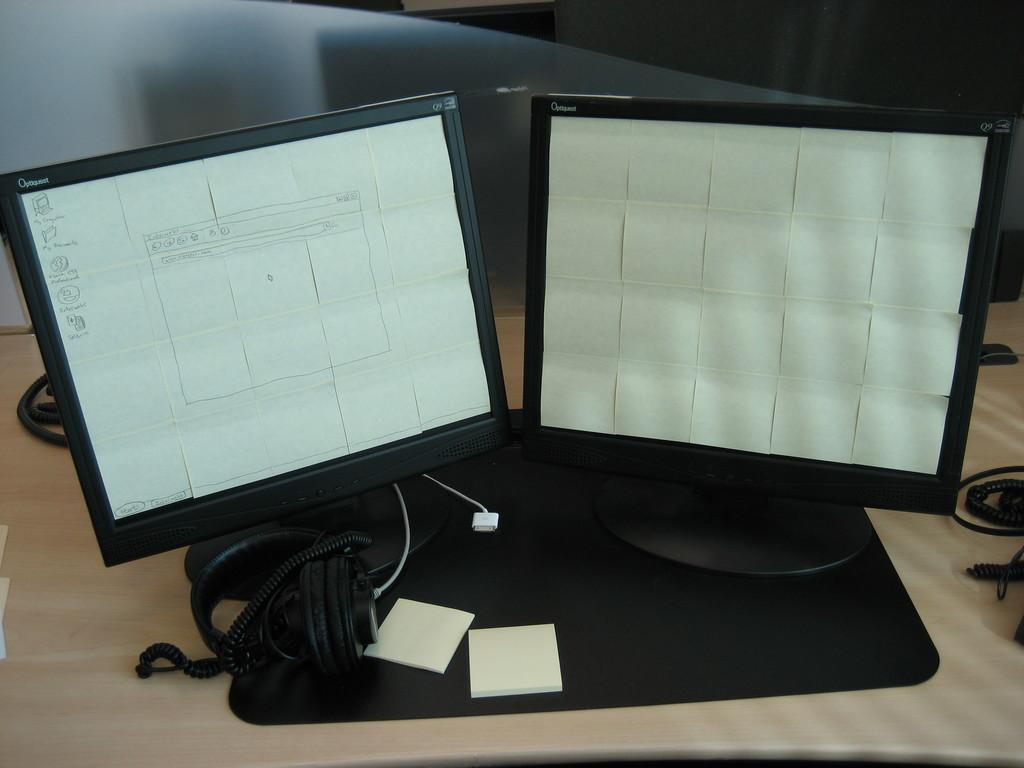What can be seen on the table in the image? There are monitors on the table. What type of audio device is present in the image? There is a headphone in the image. What is placed on top of the monitors? There are papers on the monitors. What type of office supply is visible on the table? There are paper clips on the table. What sense does the sidewalk in the image appeal to? There is no sidewalk present in the image, so it cannot appeal to any sense. 